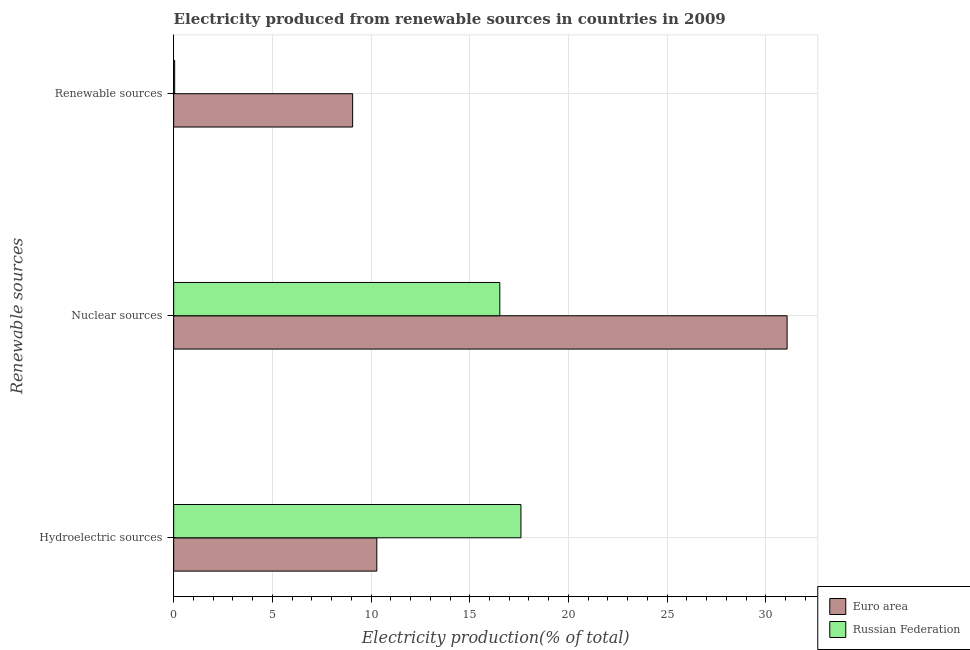How many different coloured bars are there?
Provide a succinct answer. 2. Are the number of bars per tick equal to the number of legend labels?
Ensure brevity in your answer.  Yes. How many bars are there on the 3rd tick from the bottom?
Offer a very short reply. 2. What is the label of the 1st group of bars from the top?
Your answer should be very brief. Renewable sources. What is the percentage of electricity produced by renewable sources in Russian Federation?
Make the answer very short. 0.05. Across all countries, what is the maximum percentage of electricity produced by hydroelectric sources?
Give a very brief answer. 17.59. Across all countries, what is the minimum percentage of electricity produced by renewable sources?
Offer a terse response. 0.05. In which country was the percentage of electricity produced by renewable sources maximum?
Your answer should be very brief. Euro area. What is the total percentage of electricity produced by nuclear sources in the graph?
Ensure brevity in your answer.  47.6. What is the difference between the percentage of electricity produced by hydroelectric sources in Russian Federation and that in Euro area?
Offer a very short reply. 7.3. What is the difference between the percentage of electricity produced by hydroelectric sources in Russian Federation and the percentage of electricity produced by renewable sources in Euro area?
Provide a succinct answer. 8.53. What is the average percentage of electricity produced by renewable sources per country?
Provide a succinct answer. 4.56. What is the difference between the percentage of electricity produced by renewable sources and percentage of electricity produced by hydroelectric sources in Euro area?
Provide a succinct answer. -1.22. In how many countries, is the percentage of electricity produced by hydroelectric sources greater than 1 %?
Offer a very short reply. 2. What is the ratio of the percentage of electricity produced by renewable sources in Euro area to that in Russian Federation?
Ensure brevity in your answer.  179.17. Is the difference between the percentage of electricity produced by hydroelectric sources in Euro area and Russian Federation greater than the difference between the percentage of electricity produced by renewable sources in Euro area and Russian Federation?
Provide a succinct answer. No. What is the difference between the highest and the second highest percentage of electricity produced by hydroelectric sources?
Keep it short and to the point. 7.3. What is the difference between the highest and the lowest percentage of electricity produced by nuclear sources?
Your answer should be very brief. 14.55. In how many countries, is the percentage of electricity produced by renewable sources greater than the average percentage of electricity produced by renewable sources taken over all countries?
Offer a very short reply. 1. What does the 1st bar from the top in Nuclear sources represents?
Give a very brief answer. Russian Federation. How many countries are there in the graph?
Your response must be concise. 2. What is the difference between two consecutive major ticks on the X-axis?
Ensure brevity in your answer.  5. How are the legend labels stacked?
Provide a succinct answer. Vertical. What is the title of the graph?
Keep it short and to the point. Electricity produced from renewable sources in countries in 2009. Does "Niger" appear as one of the legend labels in the graph?
Ensure brevity in your answer.  No. What is the label or title of the X-axis?
Your answer should be very brief. Electricity production(% of total). What is the label or title of the Y-axis?
Provide a short and direct response. Renewable sources. What is the Electricity production(% of total) of Euro area in Hydroelectric sources?
Your answer should be compact. 10.29. What is the Electricity production(% of total) of Russian Federation in Hydroelectric sources?
Keep it short and to the point. 17.59. What is the Electricity production(% of total) of Euro area in Nuclear sources?
Provide a short and direct response. 31.08. What is the Electricity production(% of total) of Russian Federation in Nuclear sources?
Keep it short and to the point. 16.52. What is the Electricity production(% of total) of Euro area in Renewable sources?
Keep it short and to the point. 9.07. What is the Electricity production(% of total) in Russian Federation in Renewable sources?
Give a very brief answer. 0.05. Across all Renewable sources, what is the maximum Electricity production(% of total) of Euro area?
Your answer should be compact. 31.08. Across all Renewable sources, what is the maximum Electricity production(% of total) in Russian Federation?
Provide a short and direct response. 17.59. Across all Renewable sources, what is the minimum Electricity production(% of total) of Euro area?
Make the answer very short. 9.07. Across all Renewable sources, what is the minimum Electricity production(% of total) of Russian Federation?
Provide a succinct answer. 0.05. What is the total Electricity production(% of total) of Euro area in the graph?
Your answer should be compact. 50.44. What is the total Electricity production(% of total) in Russian Federation in the graph?
Give a very brief answer. 34.17. What is the difference between the Electricity production(% of total) of Euro area in Hydroelectric sources and that in Nuclear sources?
Provide a short and direct response. -20.79. What is the difference between the Electricity production(% of total) of Russian Federation in Hydroelectric sources and that in Nuclear sources?
Make the answer very short. 1.07. What is the difference between the Electricity production(% of total) of Euro area in Hydroelectric sources and that in Renewable sources?
Your answer should be compact. 1.22. What is the difference between the Electricity production(% of total) in Russian Federation in Hydroelectric sources and that in Renewable sources?
Give a very brief answer. 17.54. What is the difference between the Electricity production(% of total) of Euro area in Nuclear sources and that in Renewable sources?
Provide a succinct answer. 22.01. What is the difference between the Electricity production(% of total) in Russian Federation in Nuclear sources and that in Renewable sources?
Your answer should be very brief. 16.47. What is the difference between the Electricity production(% of total) of Euro area in Hydroelectric sources and the Electricity production(% of total) of Russian Federation in Nuclear sources?
Your answer should be very brief. -6.23. What is the difference between the Electricity production(% of total) in Euro area in Hydroelectric sources and the Electricity production(% of total) in Russian Federation in Renewable sources?
Provide a succinct answer. 10.24. What is the difference between the Electricity production(% of total) of Euro area in Nuclear sources and the Electricity production(% of total) of Russian Federation in Renewable sources?
Give a very brief answer. 31.03. What is the average Electricity production(% of total) in Euro area per Renewable sources?
Offer a terse response. 16.81. What is the average Electricity production(% of total) in Russian Federation per Renewable sources?
Offer a very short reply. 11.39. What is the difference between the Electricity production(% of total) of Euro area and Electricity production(% of total) of Russian Federation in Hydroelectric sources?
Your answer should be compact. -7.3. What is the difference between the Electricity production(% of total) of Euro area and Electricity production(% of total) of Russian Federation in Nuclear sources?
Offer a terse response. 14.55. What is the difference between the Electricity production(% of total) of Euro area and Electricity production(% of total) of Russian Federation in Renewable sources?
Your answer should be compact. 9.02. What is the ratio of the Electricity production(% of total) of Euro area in Hydroelectric sources to that in Nuclear sources?
Ensure brevity in your answer.  0.33. What is the ratio of the Electricity production(% of total) in Russian Federation in Hydroelectric sources to that in Nuclear sources?
Your answer should be very brief. 1.06. What is the ratio of the Electricity production(% of total) of Euro area in Hydroelectric sources to that in Renewable sources?
Keep it short and to the point. 1.14. What is the ratio of the Electricity production(% of total) of Russian Federation in Hydroelectric sources to that in Renewable sources?
Provide a short and direct response. 347.67. What is the ratio of the Electricity production(% of total) of Euro area in Nuclear sources to that in Renewable sources?
Your answer should be very brief. 3.43. What is the ratio of the Electricity production(% of total) of Russian Federation in Nuclear sources to that in Renewable sources?
Your answer should be compact. 326.51. What is the difference between the highest and the second highest Electricity production(% of total) in Euro area?
Provide a short and direct response. 20.79. What is the difference between the highest and the second highest Electricity production(% of total) in Russian Federation?
Your answer should be compact. 1.07. What is the difference between the highest and the lowest Electricity production(% of total) in Euro area?
Keep it short and to the point. 22.01. What is the difference between the highest and the lowest Electricity production(% of total) in Russian Federation?
Your answer should be compact. 17.54. 